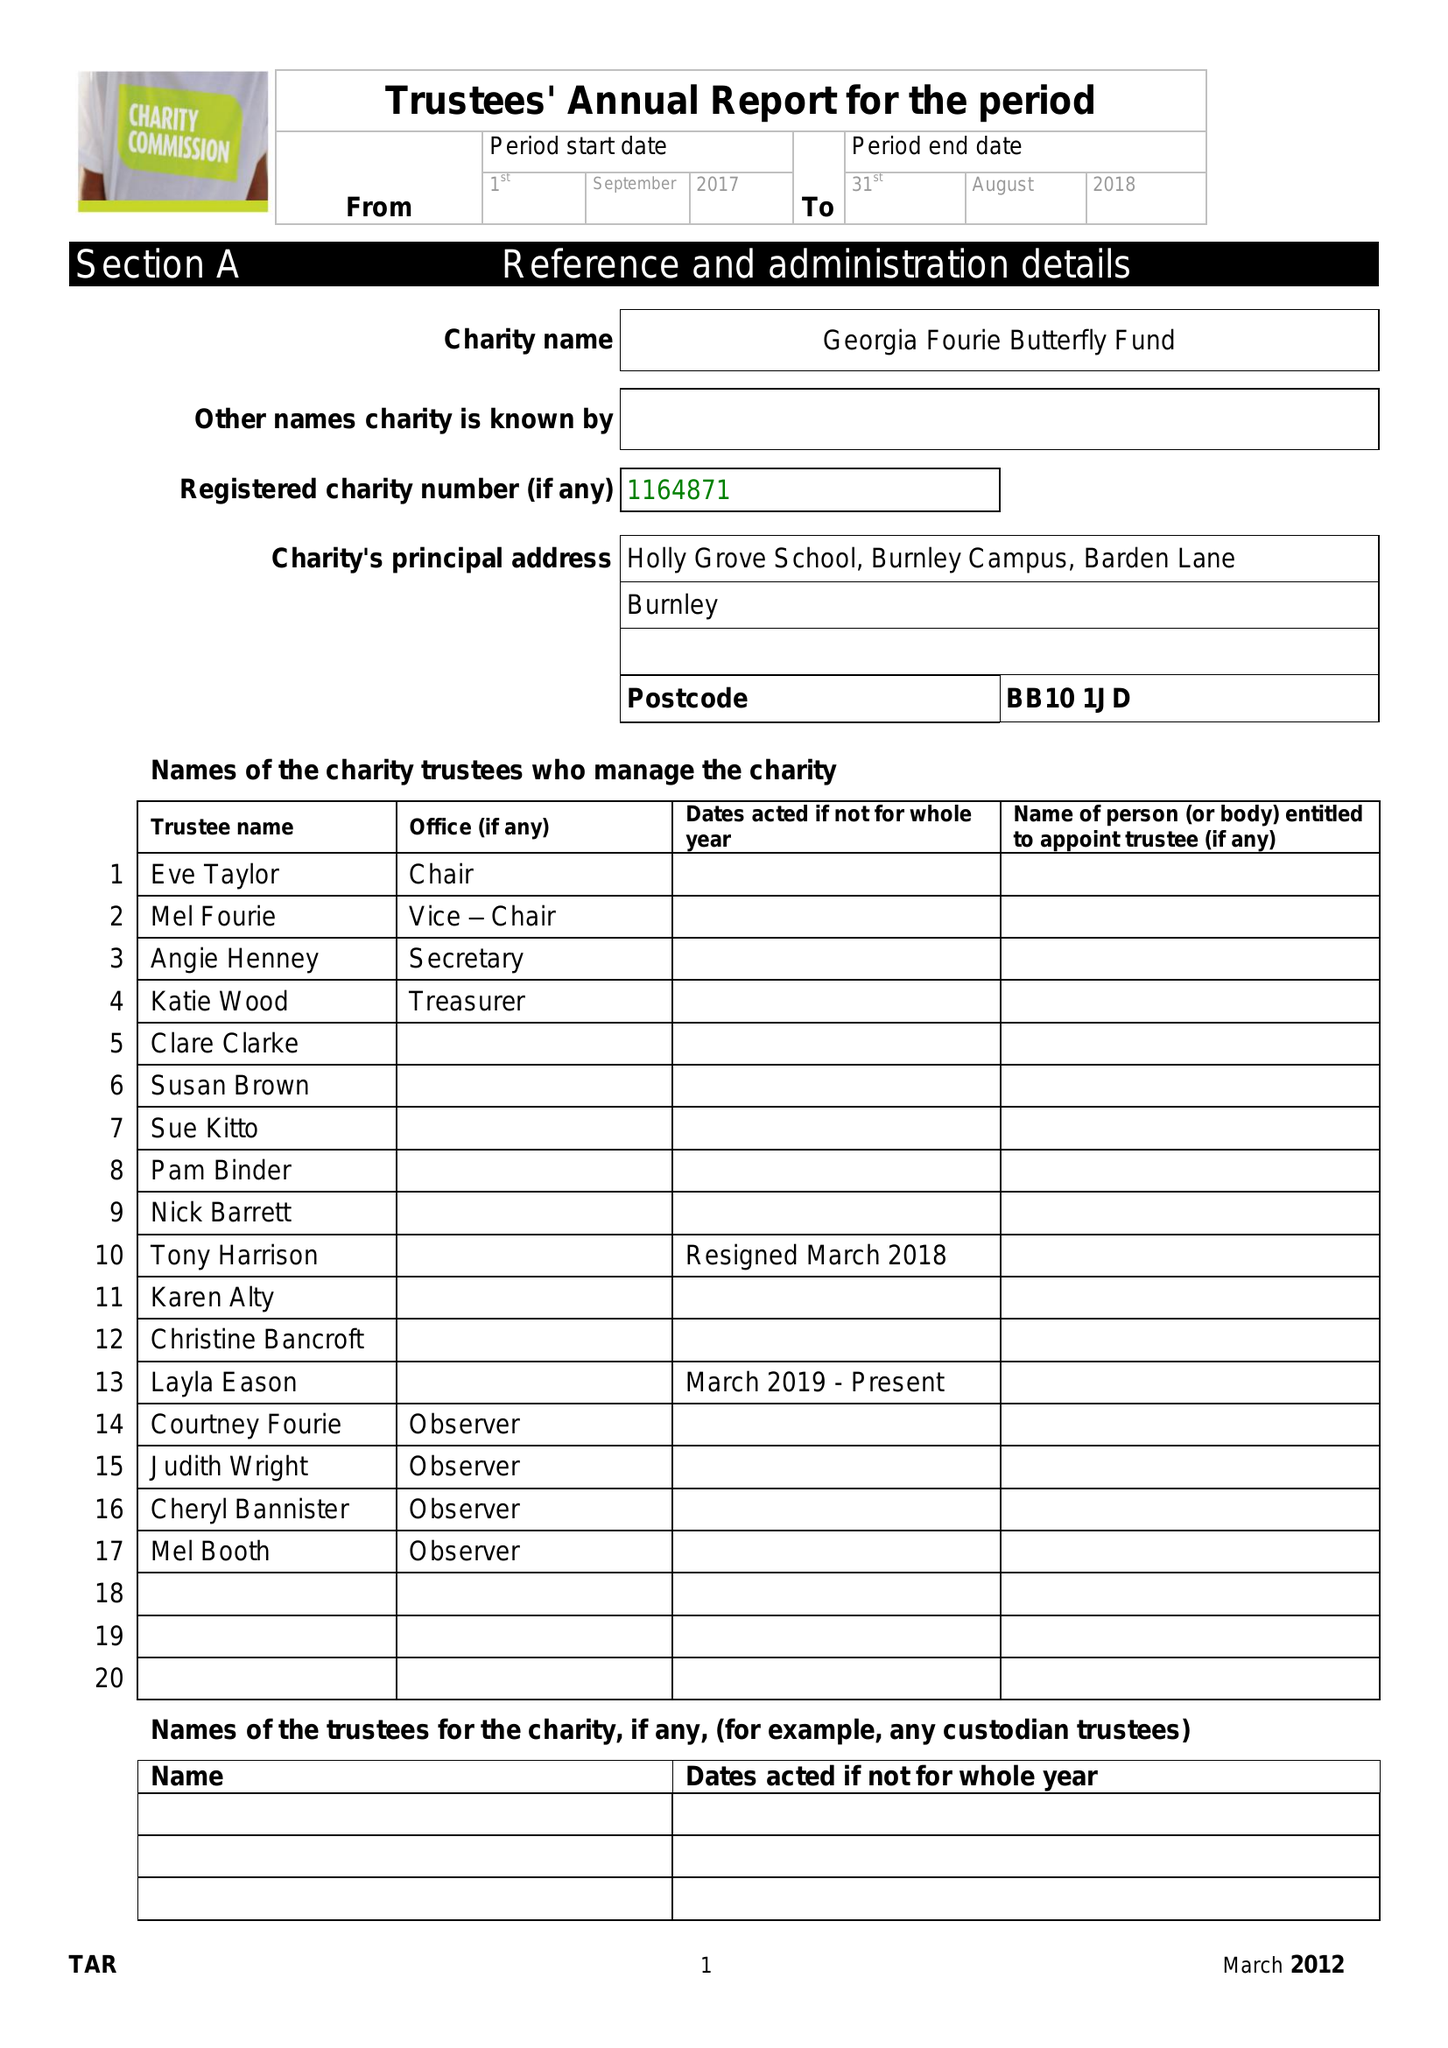What is the value for the report_date?
Answer the question using a single word or phrase. 2018-08-31 